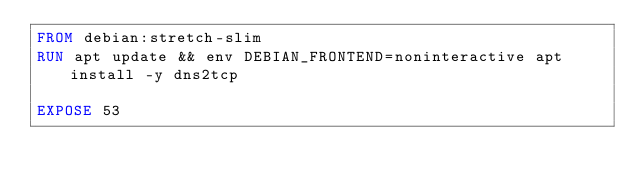Convert code to text. <code><loc_0><loc_0><loc_500><loc_500><_Dockerfile_>FROM debian:stretch-slim
RUN apt update && env DEBIAN_FRONTEND=noninteractive apt install -y dns2tcp

EXPOSE 53</code> 